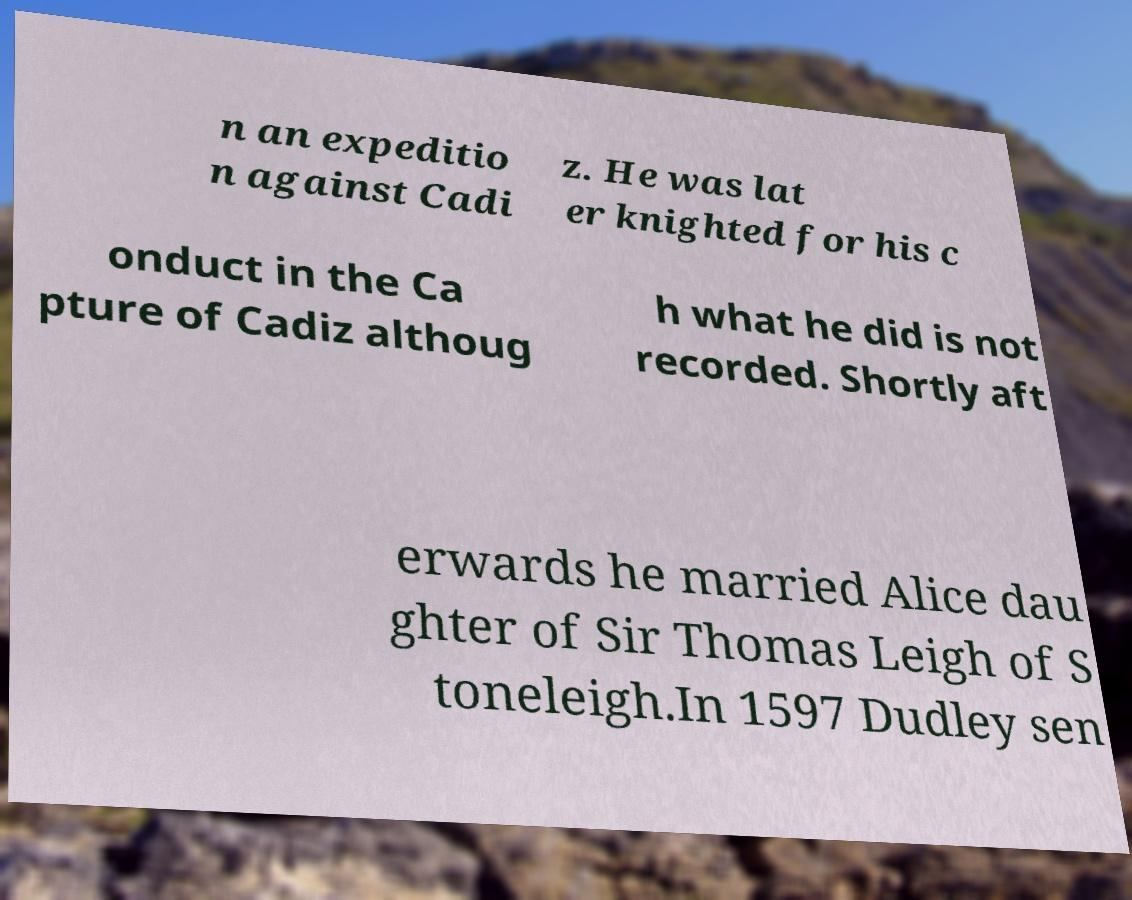What messages or text are displayed in this image? I need them in a readable, typed format. n an expeditio n against Cadi z. He was lat er knighted for his c onduct in the Ca pture of Cadiz althoug h what he did is not recorded. Shortly aft erwards he married Alice dau ghter of Sir Thomas Leigh of S toneleigh.In 1597 Dudley sen 